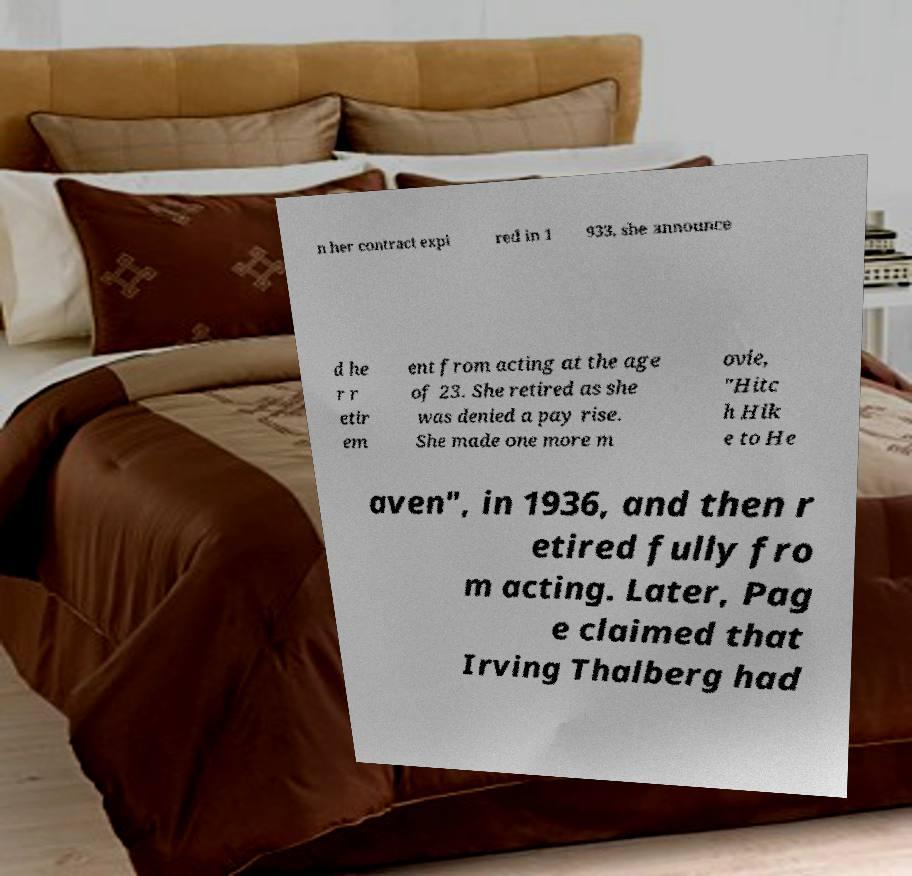For documentation purposes, I need the text within this image transcribed. Could you provide that? n her contract expi red in 1 933, she announce d he r r etir em ent from acting at the age of 23. She retired as she was denied a pay rise. She made one more m ovie, "Hitc h Hik e to He aven", in 1936, and then r etired fully fro m acting. Later, Pag e claimed that Irving Thalberg had 